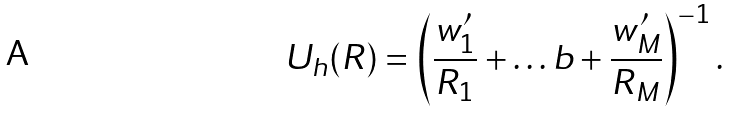<formula> <loc_0><loc_0><loc_500><loc_500>U _ { h } ( R ) & = \left ( \frac { w _ { 1 } ^ { \prime } } { R _ { 1 } } + \dots b + \frac { w _ { M } ^ { \prime } } { R _ { M } } \right ) ^ { - 1 } .</formula> 